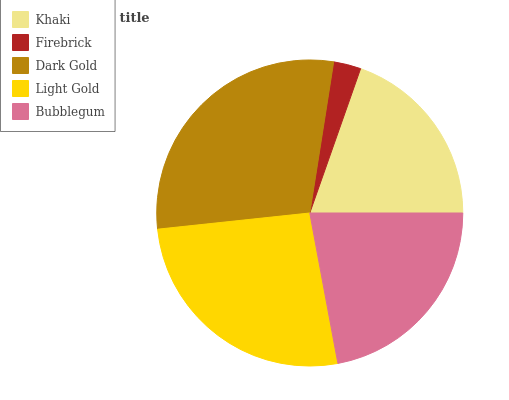Is Firebrick the minimum?
Answer yes or no. Yes. Is Dark Gold the maximum?
Answer yes or no. Yes. Is Dark Gold the minimum?
Answer yes or no. No. Is Firebrick the maximum?
Answer yes or no. No. Is Dark Gold greater than Firebrick?
Answer yes or no. Yes. Is Firebrick less than Dark Gold?
Answer yes or no. Yes. Is Firebrick greater than Dark Gold?
Answer yes or no. No. Is Dark Gold less than Firebrick?
Answer yes or no. No. Is Bubblegum the high median?
Answer yes or no. Yes. Is Bubblegum the low median?
Answer yes or no. Yes. Is Light Gold the high median?
Answer yes or no. No. Is Light Gold the low median?
Answer yes or no. No. 